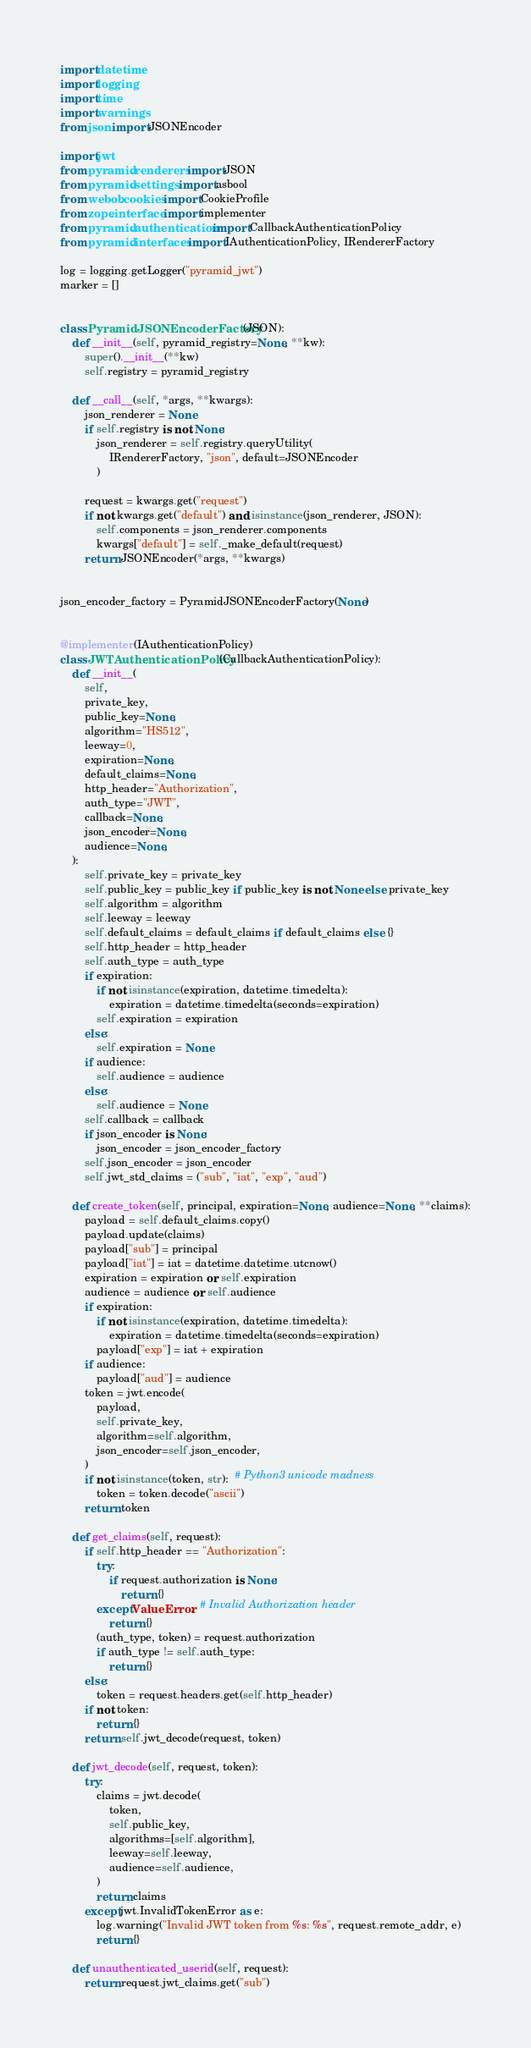<code> <loc_0><loc_0><loc_500><loc_500><_Python_>import datetime
import logging
import time
import warnings
from json import JSONEncoder

import jwt
from pyramid.renderers import JSON
from pyramid.settings import asbool
from webob.cookies import CookieProfile
from zope.interface import implementer
from pyramid.authentication import CallbackAuthenticationPolicy
from pyramid.interfaces import IAuthenticationPolicy, IRendererFactory

log = logging.getLogger("pyramid_jwt")
marker = []


class PyramidJSONEncoderFactory(JSON):
    def __init__(self, pyramid_registry=None, **kw):
        super().__init__(**kw)
        self.registry = pyramid_registry

    def __call__(self, *args, **kwargs):
        json_renderer = None
        if self.registry is not None:
            json_renderer = self.registry.queryUtility(
                IRendererFactory, "json", default=JSONEncoder
            )

        request = kwargs.get("request")
        if not kwargs.get("default") and isinstance(json_renderer, JSON):
            self.components = json_renderer.components
            kwargs["default"] = self._make_default(request)
        return JSONEncoder(*args, **kwargs)


json_encoder_factory = PyramidJSONEncoderFactory(None)


@implementer(IAuthenticationPolicy)
class JWTAuthenticationPolicy(CallbackAuthenticationPolicy):
    def __init__(
        self,
        private_key,
        public_key=None,
        algorithm="HS512",
        leeway=0,
        expiration=None,
        default_claims=None,
        http_header="Authorization",
        auth_type="JWT",
        callback=None,
        json_encoder=None,
        audience=None,
    ):
        self.private_key = private_key
        self.public_key = public_key if public_key is not None else private_key
        self.algorithm = algorithm
        self.leeway = leeway
        self.default_claims = default_claims if default_claims else {}
        self.http_header = http_header
        self.auth_type = auth_type
        if expiration:
            if not isinstance(expiration, datetime.timedelta):
                expiration = datetime.timedelta(seconds=expiration)
            self.expiration = expiration
        else:
            self.expiration = None
        if audience:
            self.audience = audience
        else:
            self.audience = None
        self.callback = callback
        if json_encoder is None:
            json_encoder = json_encoder_factory
        self.json_encoder = json_encoder
        self.jwt_std_claims = ("sub", "iat", "exp", "aud")

    def create_token(self, principal, expiration=None, audience=None, **claims):
        payload = self.default_claims.copy()
        payload.update(claims)
        payload["sub"] = principal
        payload["iat"] = iat = datetime.datetime.utcnow()
        expiration = expiration or self.expiration
        audience = audience or self.audience
        if expiration:
            if not isinstance(expiration, datetime.timedelta):
                expiration = datetime.timedelta(seconds=expiration)
            payload["exp"] = iat + expiration
        if audience:
            payload["aud"] = audience
        token = jwt.encode(
            payload,
            self.private_key,
            algorithm=self.algorithm,
            json_encoder=self.json_encoder,
        )
        if not isinstance(token, str):  # Python3 unicode madness
            token = token.decode("ascii")
        return token

    def get_claims(self, request):
        if self.http_header == "Authorization":
            try:
                if request.authorization is None:
                    return {}
            except ValueError:  # Invalid Authorization header
                return {}
            (auth_type, token) = request.authorization
            if auth_type != self.auth_type:
                return {}
        else:
            token = request.headers.get(self.http_header)
        if not token:
            return {}
        return self.jwt_decode(request, token)

    def jwt_decode(self, request, token):
        try:
            claims = jwt.decode(
                token,
                self.public_key,
                algorithms=[self.algorithm],
                leeway=self.leeway,
                audience=self.audience,
            )
            return claims
        except jwt.InvalidTokenError as e:
            log.warning("Invalid JWT token from %s: %s", request.remote_addr, e)
            return {}

    def unauthenticated_userid(self, request):
        return request.jwt_claims.get("sub")
</code> 